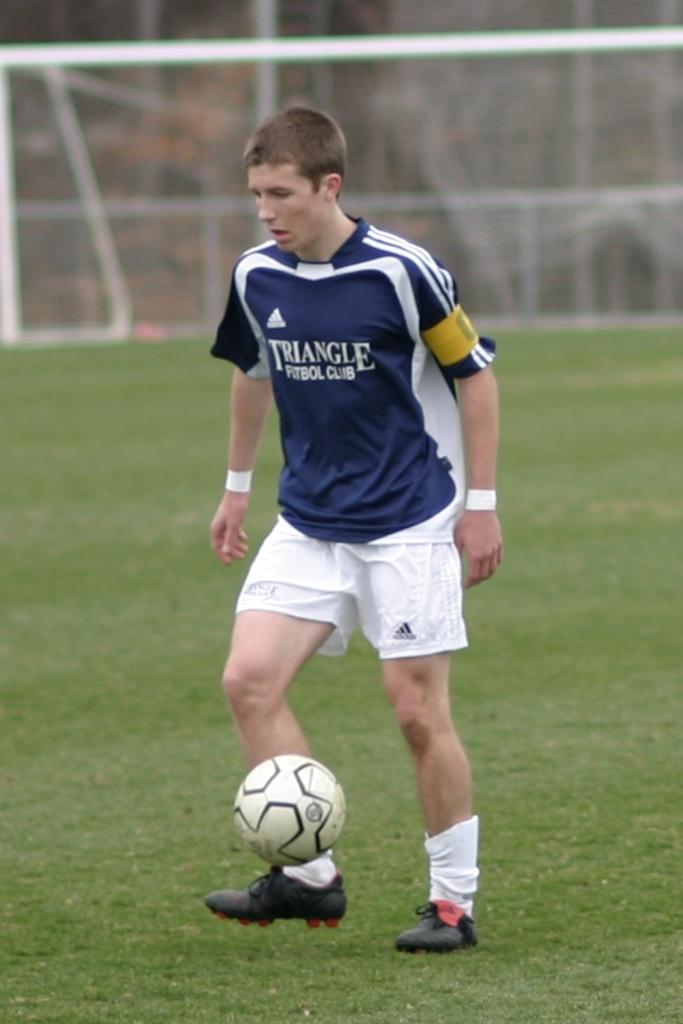<image>
Present a compact description of the photo's key features. a soccer player wearing a blue jersey that says triangle futbol club 